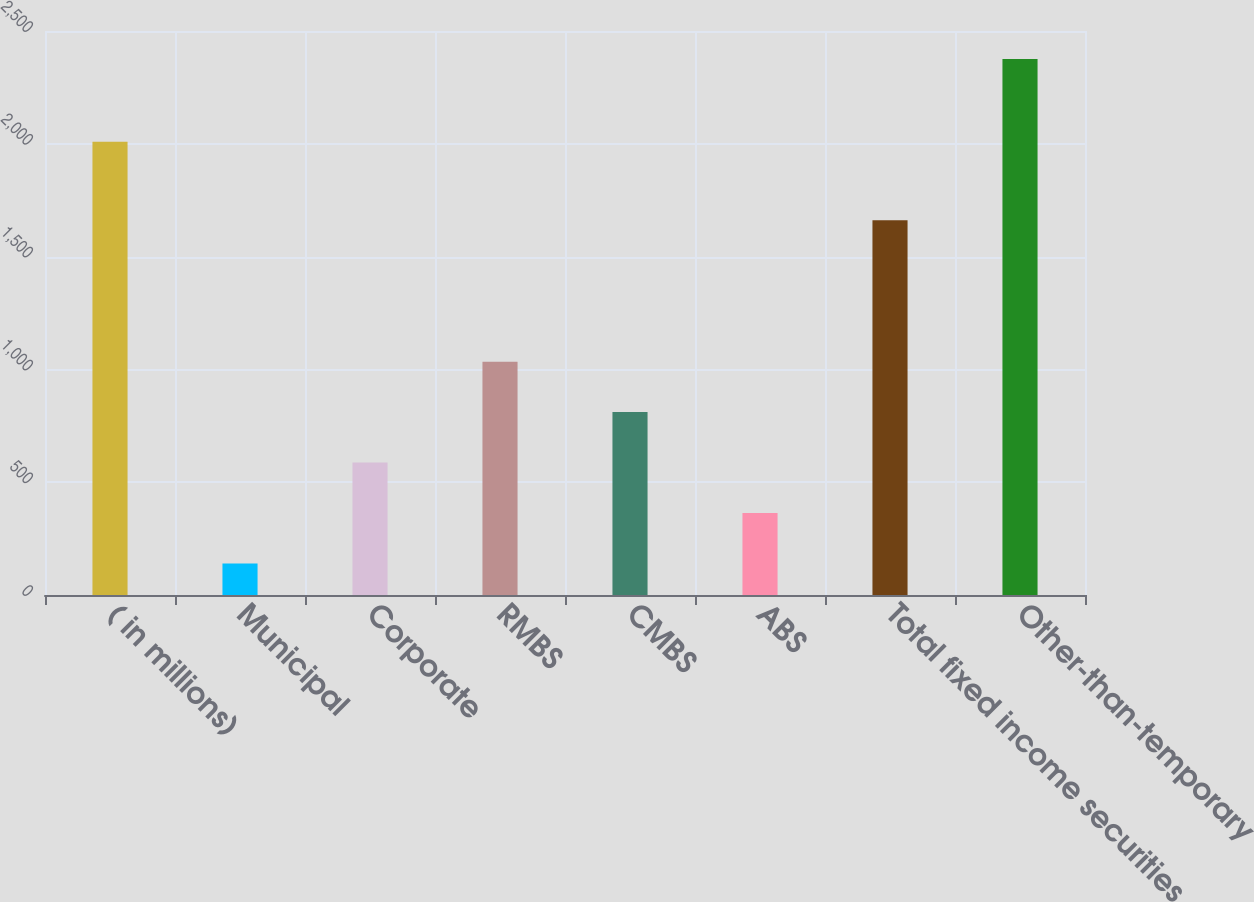<chart> <loc_0><loc_0><loc_500><loc_500><bar_chart><fcel>( in millions)<fcel>Municipal<fcel>Corporate<fcel>RMBS<fcel>CMBS<fcel>ABS<fcel>Total fixed income securities<fcel>Other-than-temporary<nl><fcel>2009<fcel>140<fcel>587.2<fcel>1034.4<fcel>810.8<fcel>363.6<fcel>1661<fcel>2376<nl></chart> 